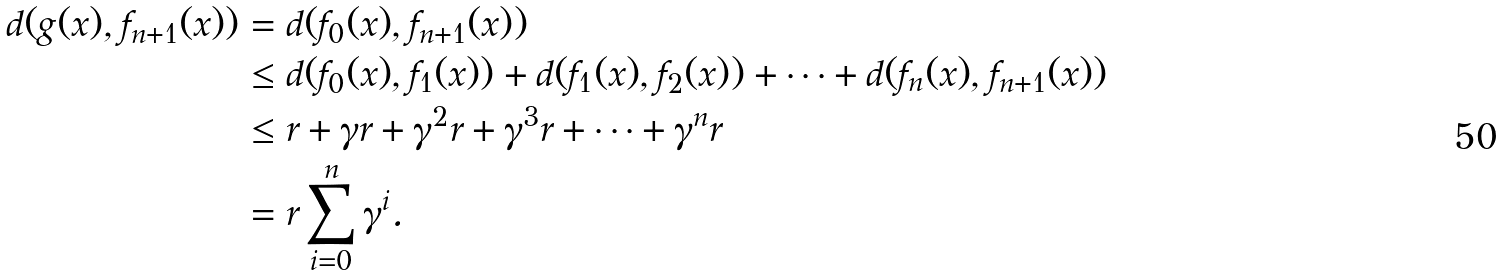Convert formula to latex. <formula><loc_0><loc_0><loc_500><loc_500>d ( g ( x ) , f _ { n + 1 } ( x ) ) & = d ( f _ { 0 } ( x ) , f _ { n + 1 } ( x ) ) \\ & \leq d ( f _ { 0 } ( x ) , f _ { 1 } ( x ) ) + d ( f _ { 1 } ( x ) , f _ { 2 } ( x ) ) + \cdots + d ( f _ { n } ( x ) , f _ { n + 1 } ( x ) ) \\ & \leq r + \gamma r + \gamma ^ { 2 } r + \gamma ^ { 3 } r + \cdots + \gamma ^ { n } r \\ & = r \sum _ { i = 0 } ^ { n } \gamma ^ { i } .</formula> 